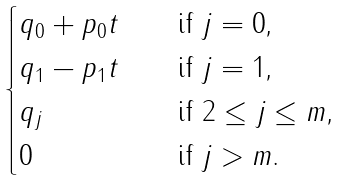<formula> <loc_0><loc_0><loc_500><loc_500>\begin{cases} q _ { 0 } + p _ { 0 } t & \quad \text {if $j=0$,} \\ q _ { 1 } - p _ { 1 } t & \quad \text {if $j=1$,} \\ q _ { j } & \quad \text {if $2\leq j\leq m$,} \\ 0 & \quad \text {if $j>m$.} \\ \end{cases}</formula> 